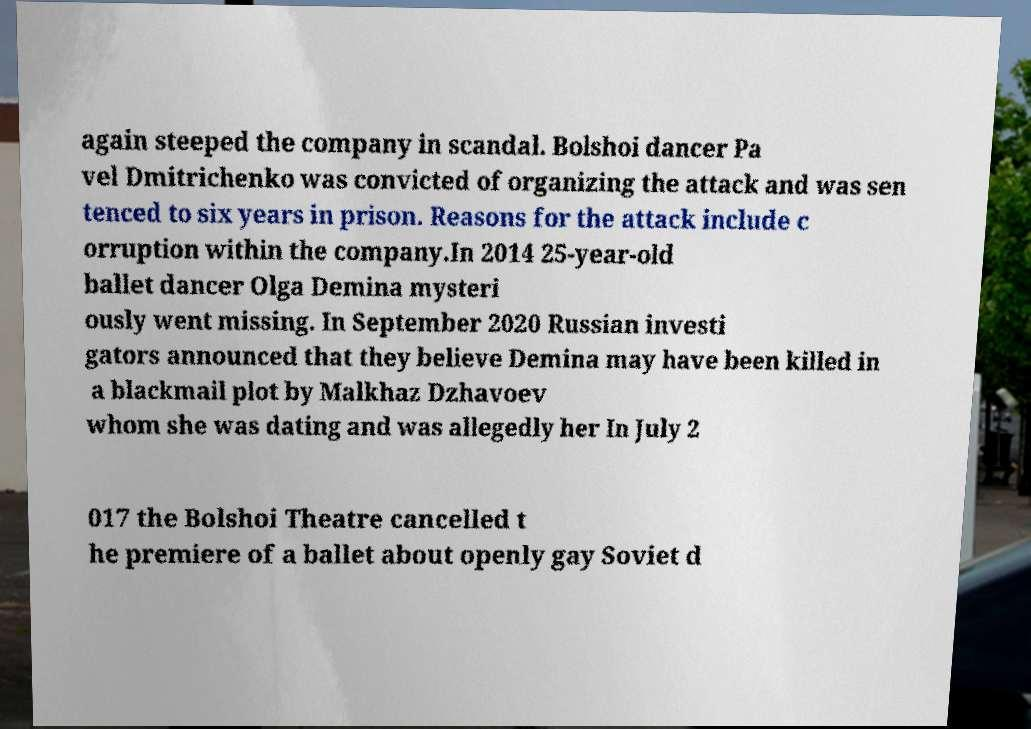Could you extract and type out the text from this image? again steeped the company in scandal. Bolshoi dancer Pa vel Dmitrichenko was convicted of organizing the attack and was sen tenced to six years in prison. Reasons for the attack include c orruption within the company.In 2014 25-year-old ballet dancer Olga Demina mysteri ously went missing. In September 2020 Russian investi gators announced that they believe Demina may have been killed in a blackmail plot by Malkhaz Dzhavoev whom she was dating and was allegedly her In July 2 017 the Bolshoi Theatre cancelled t he premiere of a ballet about openly gay Soviet d 